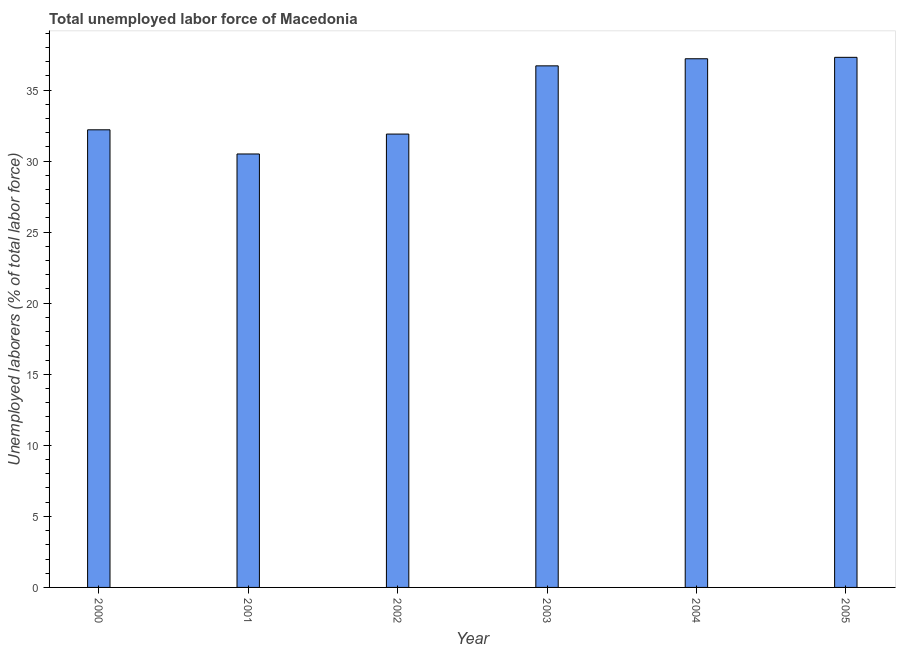Does the graph contain any zero values?
Offer a terse response. No. What is the title of the graph?
Make the answer very short. Total unemployed labor force of Macedonia. What is the label or title of the X-axis?
Give a very brief answer. Year. What is the label or title of the Y-axis?
Your answer should be compact. Unemployed laborers (% of total labor force). What is the total unemployed labour force in 2000?
Provide a short and direct response. 32.2. Across all years, what is the maximum total unemployed labour force?
Ensure brevity in your answer.  37.3. Across all years, what is the minimum total unemployed labour force?
Your answer should be very brief. 30.5. In which year was the total unemployed labour force maximum?
Your answer should be very brief. 2005. What is the sum of the total unemployed labour force?
Offer a terse response. 205.8. What is the average total unemployed labour force per year?
Ensure brevity in your answer.  34.3. What is the median total unemployed labour force?
Keep it short and to the point. 34.45. In how many years, is the total unemployed labour force greater than 18 %?
Your answer should be compact. 6. Do a majority of the years between 2002 and 2005 (inclusive) have total unemployed labour force greater than 20 %?
Your answer should be very brief. Yes. What is the ratio of the total unemployed labour force in 2000 to that in 2001?
Ensure brevity in your answer.  1.06. Is the total unemployed labour force in 2003 less than that in 2004?
Your answer should be very brief. Yes. What is the difference between the highest and the second highest total unemployed labour force?
Offer a very short reply. 0.1. What is the difference between the highest and the lowest total unemployed labour force?
Keep it short and to the point. 6.8. In how many years, is the total unemployed labour force greater than the average total unemployed labour force taken over all years?
Make the answer very short. 3. How many bars are there?
Keep it short and to the point. 6. Are all the bars in the graph horizontal?
Keep it short and to the point. No. How many years are there in the graph?
Provide a short and direct response. 6. What is the difference between two consecutive major ticks on the Y-axis?
Provide a succinct answer. 5. What is the Unemployed laborers (% of total labor force) of 2000?
Offer a terse response. 32.2. What is the Unemployed laborers (% of total labor force) of 2001?
Provide a short and direct response. 30.5. What is the Unemployed laborers (% of total labor force) in 2002?
Provide a succinct answer. 31.9. What is the Unemployed laborers (% of total labor force) of 2003?
Provide a short and direct response. 36.7. What is the Unemployed laborers (% of total labor force) of 2004?
Your response must be concise. 37.2. What is the Unemployed laborers (% of total labor force) of 2005?
Your answer should be compact. 37.3. What is the difference between the Unemployed laborers (% of total labor force) in 2000 and 2002?
Offer a terse response. 0.3. What is the difference between the Unemployed laborers (% of total labor force) in 2000 and 2005?
Your response must be concise. -5.1. What is the difference between the Unemployed laborers (% of total labor force) in 2001 and 2003?
Ensure brevity in your answer.  -6.2. What is the difference between the Unemployed laborers (% of total labor force) in 2001 and 2004?
Keep it short and to the point. -6.7. What is the difference between the Unemployed laborers (% of total labor force) in 2002 and 2004?
Offer a very short reply. -5.3. What is the difference between the Unemployed laborers (% of total labor force) in 2003 and 2004?
Offer a terse response. -0.5. What is the ratio of the Unemployed laborers (% of total labor force) in 2000 to that in 2001?
Provide a short and direct response. 1.06. What is the ratio of the Unemployed laborers (% of total labor force) in 2000 to that in 2003?
Give a very brief answer. 0.88. What is the ratio of the Unemployed laborers (% of total labor force) in 2000 to that in 2004?
Give a very brief answer. 0.87. What is the ratio of the Unemployed laborers (% of total labor force) in 2000 to that in 2005?
Your answer should be compact. 0.86. What is the ratio of the Unemployed laborers (% of total labor force) in 2001 to that in 2002?
Your answer should be very brief. 0.96. What is the ratio of the Unemployed laborers (% of total labor force) in 2001 to that in 2003?
Provide a short and direct response. 0.83. What is the ratio of the Unemployed laborers (% of total labor force) in 2001 to that in 2004?
Offer a very short reply. 0.82. What is the ratio of the Unemployed laborers (% of total labor force) in 2001 to that in 2005?
Keep it short and to the point. 0.82. What is the ratio of the Unemployed laborers (% of total labor force) in 2002 to that in 2003?
Offer a terse response. 0.87. What is the ratio of the Unemployed laborers (% of total labor force) in 2002 to that in 2004?
Offer a very short reply. 0.86. What is the ratio of the Unemployed laborers (% of total labor force) in 2002 to that in 2005?
Your answer should be very brief. 0.85. What is the ratio of the Unemployed laborers (% of total labor force) in 2003 to that in 2004?
Your answer should be very brief. 0.99. What is the ratio of the Unemployed laborers (% of total labor force) in 2003 to that in 2005?
Give a very brief answer. 0.98. 